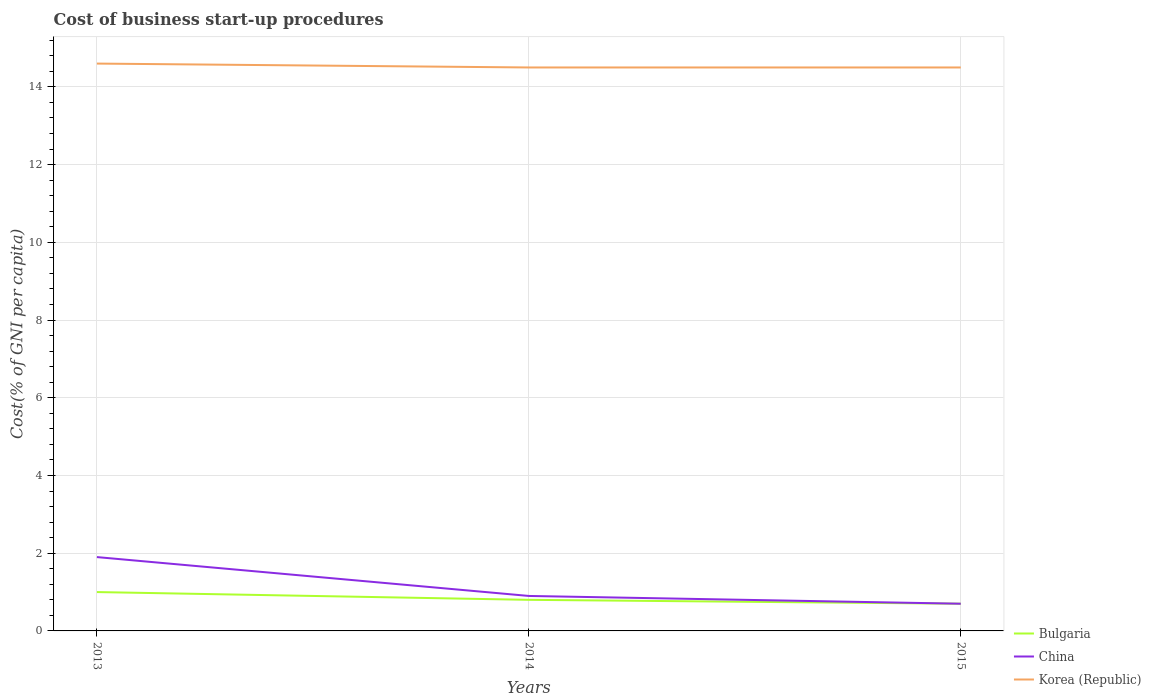How many different coloured lines are there?
Your response must be concise. 3. Does the line corresponding to China intersect with the line corresponding to Korea (Republic)?
Keep it short and to the point. No. Is the number of lines equal to the number of legend labels?
Your answer should be very brief. Yes. Across all years, what is the maximum cost of business start-up procedures in Bulgaria?
Offer a terse response. 0.7. In which year was the cost of business start-up procedures in China maximum?
Your answer should be very brief. 2015. What is the total cost of business start-up procedures in Korea (Republic) in the graph?
Make the answer very short. 0.1. What is the difference between the highest and the second highest cost of business start-up procedures in China?
Give a very brief answer. 1.2. What is the difference between the highest and the lowest cost of business start-up procedures in Bulgaria?
Keep it short and to the point. 1. What is the difference between two consecutive major ticks on the Y-axis?
Your response must be concise. 2. Are the values on the major ticks of Y-axis written in scientific E-notation?
Make the answer very short. No. Does the graph contain any zero values?
Provide a succinct answer. No. Does the graph contain grids?
Ensure brevity in your answer.  Yes. Where does the legend appear in the graph?
Your answer should be compact. Bottom right. How many legend labels are there?
Make the answer very short. 3. How are the legend labels stacked?
Your response must be concise. Vertical. What is the title of the graph?
Your answer should be compact. Cost of business start-up procedures. Does "Belgium" appear as one of the legend labels in the graph?
Make the answer very short. No. What is the label or title of the X-axis?
Provide a succinct answer. Years. What is the label or title of the Y-axis?
Ensure brevity in your answer.  Cost(% of GNI per capita). What is the Cost(% of GNI per capita) in Bulgaria in 2013?
Offer a terse response. 1. What is the Cost(% of GNI per capita) of China in 2013?
Your answer should be compact. 1.9. What is the Cost(% of GNI per capita) of Korea (Republic) in 2013?
Offer a very short reply. 14.6. What is the Cost(% of GNI per capita) in Bulgaria in 2014?
Offer a very short reply. 0.8. What is the Cost(% of GNI per capita) of Bulgaria in 2015?
Give a very brief answer. 0.7. What is the Cost(% of GNI per capita) of China in 2015?
Keep it short and to the point. 0.7. What is the Cost(% of GNI per capita) in Korea (Republic) in 2015?
Your response must be concise. 14.5. Across all years, what is the maximum Cost(% of GNI per capita) of Bulgaria?
Make the answer very short. 1. Across all years, what is the minimum Cost(% of GNI per capita) of China?
Your response must be concise. 0.7. What is the total Cost(% of GNI per capita) of China in the graph?
Provide a succinct answer. 3.5. What is the total Cost(% of GNI per capita) in Korea (Republic) in the graph?
Your answer should be compact. 43.6. What is the difference between the Cost(% of GNI per capita) of Bulgaria in 2013 and that in 2014?
Your response must be concise. 0.2. What is the difference between the Cost(% of GNI per capita) in Korea (Republic) in 2013 and that in 2014?
Make the answer very short. 0.1. What is the difference between the Cost(% of GNI per capita) in Korea (Republic) in 2013 and that in 2015?
Give a very brief answer. 0.1. What is the difference between the Cost(% of GNI per capita) in China in 2014 and that in 2015?
Offer a terse response. 0.2. What is the difference between the Cost(% of GNI per capita) of Bulgaria in 2013 and the Cost(% of GNI per capita) of China in 2014?
Offer a very short reply. 0.1. What is the difference between the Cost(% of GNI per capita) in China in 2013 and the Cost(% of GNI per capita) in Korea (Republic) in 2014?
Offer a terse response. -12.6. What is the difference between the Cost(% of GNI per capita) of Bulgaria in 2013 and the Cost(% of GNI per capita) of China in 2015?
Provide a succinct answer. 0.3. What is the difference between the Cost(% of GNI per capita) in Bulgaria in 2013 and the Cost(% of GNI per capita) in Korea (Republic) in 2015?
Provide a succinct answer. -13.5. What is the difference between the Cost(% of GNI per capita) in China in 2013 and the Cost(% of GNI per capita) in Korea (Republic) in 2015?
Provide a short and direct response. -12.6. What is the difference between the Cost(% of GNI per capita) of Bulgaria in 2014 and the Cost(% of GNI per capita) of Korea (Republic) in 2015?
Your answer should be very brief. -13.7. What is the difference between the Cost(% of GNI per capita) in China in 2014 and the Cost(% of GNI per capita) in Korea (Republic) in 2015?
Offer a terse response. -13.6. What is the average Cost(% of GNI per capita) in Korea (Republic) per year?
Your answer should be very brief. 14.53. In the year 2013, what is the difference between the Cost(% of GNI per capita) in Bulgaria and Cost(% of GNI per capita) in China?
Your answer should be very brief. -0.9. In the year 2013, what is the difference between the Cost(% of GNI per capita) of Bulgaria and Cost(% of GNI per capita) of Korea (Republic)?
Your response must be concise. -13.6. In the year 2014, what is the difference between the Cost(% of GNI per capita) of Bulgaria and Cost(% of GNI per capita) of China?
Keep it short and to the point. -0.1. In the year 2014, what is the difference between the Cost(% of GNI per capita) of Bulgaria and Cost(% of GNI per capita) of Korea (Republic)?
Give a very brief answer. -13.7. In the year 2014, what is the difference between the Cost(% of GNI per capita) of China and Cost(% of GNI per capita) of Korea (Republic)?
Provide a short and direct response. -13.6. In the year 2015, what is the difference between the Cost(% of GNI per capita) of Bulgaria and Cost(% of GNI per capita) of China?
Your answer should be very brief. 0. In the year 2015, what is the difference between the Cost(% of GNI per capita) of Bulgaria and Cost(% of GNI per capita) of Korea (Republic)?
Ensure brevity in your answer.  -13.8. In the year 2015, what is the difference between the Cost(% of GNI per capita) in China and Cost(% of GNI per capita) in Korea (Republic)?
Ensure brevity in your answer.  -13.8. What is the ratio of the Cost(% of GNI per capita) in Bulgaria in 2013 to that in 2014?
Ensure brevity in your answer.  1.25. What is the ratio of the Cost(% of GNI per capita) in China in 2013 to that in 2014?
Provide a short and direct response. 2.11. What is the ratio of the Cost(% of GNI per capita) of Bulgaria in 2013 to that in 2015?
Your response must be concise. 1.43. What is the ratio of the Cost(% of GNI per capita) in China in 2013 to that in 2015?
Provide a succinct answer. 2.71. What is the ratio of the Cost(% of GNI per capita) of Korea (Republic) in 2013 to that in 2015?
Make the answer very short. 1.01. What is the difference between the highest and the second highest Cost(% of GNI per capita) of Bulgaria?
Provide a succinct answer. 0.2. What is the difference between the highest and the lowest Cost(% of GNI per capita) in Bulgaria?
Ensure brevity in your answer.  0.3. 